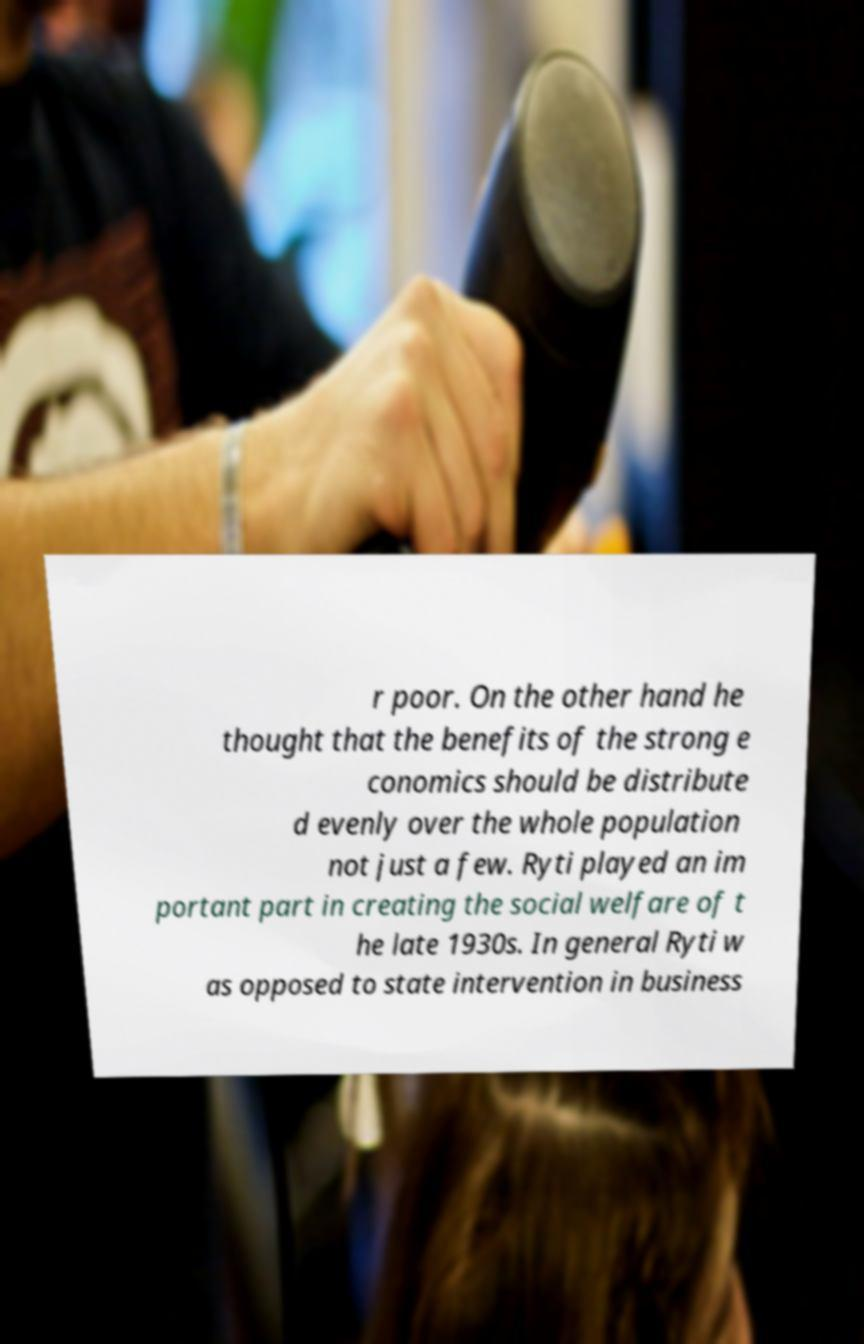Please identify and transcribe the text found in this image. r poor. On the other hand he thought that the benefits of the strong e conomics should be distribute d evenly over the whole population not just a few. Ryti played an im portant part in creating the social welfare of t he late 1930s. In general Ryti w as opposed to state intervention in business 